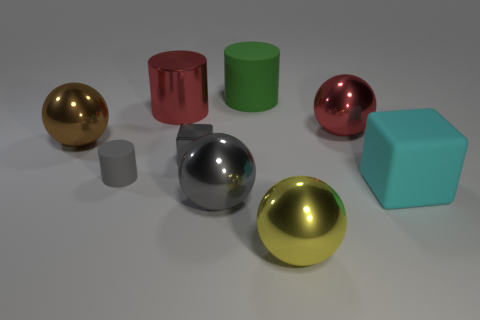Is the color of the tiny metal cube the same as the tiny rubber thing?
Offer a very short reply. Yes. There is a tiny object on the right side of the metal cylinder; is its color the same as the matte thing that is left of the big gray metallic ball?
Provide a succinct answer. Yes. Are there any balls of the same color as the small metallic thing?
Offer a very short reply. Yes. What number of large red cylinders are made of the same material as the cyan cube?
Make the answer very short. 0. What number of large things are either cyan blocks or yellow things?
Offer a terse response. 2. There is a shiny object that is behind the large brown metallic thing and to the left of the large green cylinder; what is its shape?
Your response must be concise. Cylinder. Are the green thing and the big red sphere made of the same material?
Provide a short and direct response. No. What color is the matte object that is the same size as the gray cube?
Offer a terse response. Gray. There is a rubber thing that is behind the big cube and in front of the brown thing; what color is it?
Offer a very short reply. Gray. There is a metal thing that is the same color as the tiny block; what is its size?
Your answer should be very brief. Large. 